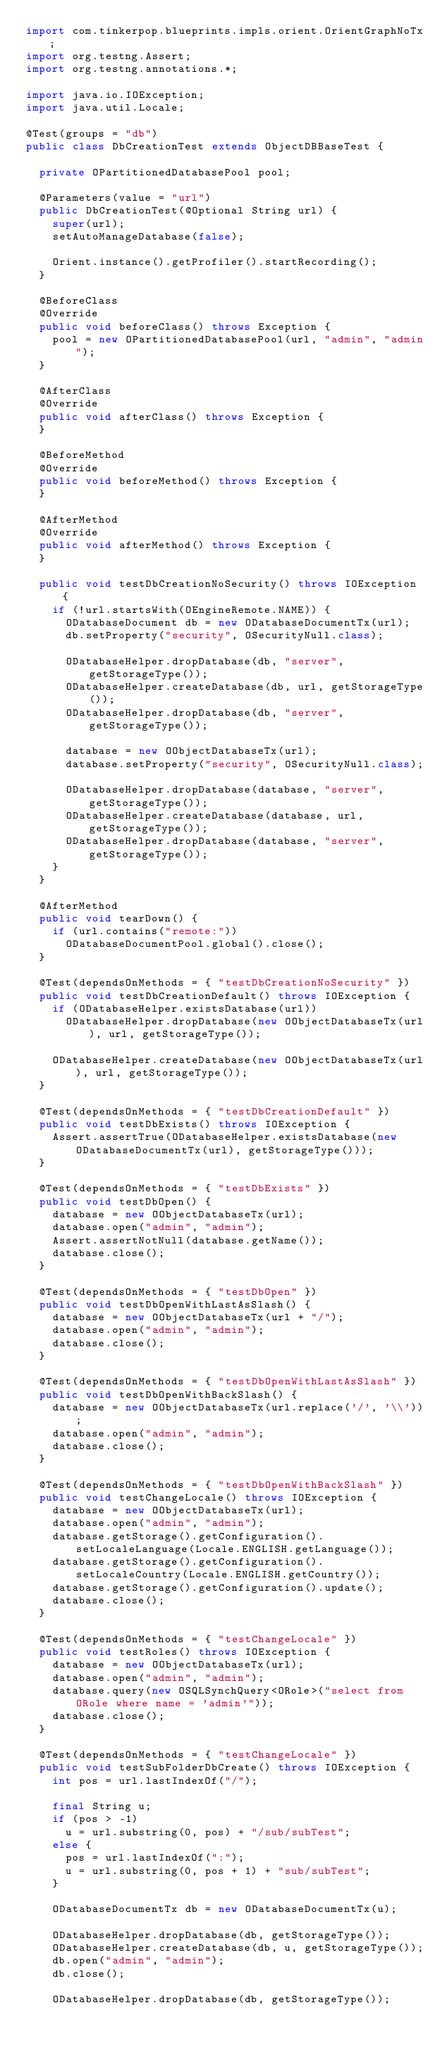<code> <loc_0><loc_0><loc_500><loc_500><_Java_>import com.tinkerpop.blueprints.impls.orient.OrientGraphNoTx;
import org.testng.Assert;
import org.testng.annotations.*;

import java.io.IOException;
import java.util.Locale;

@Test(groups = "db")
public class DbCreationTest extends ObjectDBBaseTest {

  private OPartitionedDatabasePool pool;

  @Parameters(value = "url")
  public DbCreationTest(@Optional String url) {
    super(url);
    setAutoManageDatabase(false);

    Orient.instance().getProfiler().startRecording();
  }

  @BeforeClass
  @Override
  public void beforeClass() throws Exception {
    pool = new OPartitionedDatabasePool(url, "admin", "admin");
  }

  @AfterClass
  @Override
  public void afterClass() throws Exception {
  }

  @BeforeMethod
  @Override
  public void beforeMethod() throws Exception {
  }

  @AfterMethod
  @Override
  public void afterMethod() throws Exception {
  }

  public void testDbCreationNoSecurity() throws IOException {
    if (!url.startsWith(OEngineRemote.NAME)) {
      ODatabaseDocument db = new ODatabaseDocumentTx(url);
      db.setProperty("security", OSecurityNull.class);

      ODatabaseHelper.dropDatabase(db, "server", getStorageType());
      ODatabaseHelper.createDatabase(db, url, getStorageType());
      ODatabaseHelper.dropDatabase(db, "server", getStorageType());

      database = new OObjectDatabaseTx(url);
      database.setProperty("security", OSecurityNull.class);

      ODatabaseHelper.dropDatabase(database, "server", getStorageType());
      ODatabaseHelper.createDatabase(database, url, getStorageType());
      ODatabaseHelper.dropDatabase(database, "server", getStorageType());
    }
  }

  @AfterMethod
  public void tearDown() {
    if (url.contains("remote:"))
      ODatabaseDocumentPool.global().close();
  }

  @Test(dependsOnMethods = { "testDbCreationNoSecurity" })
  public void testDbCreationDefault() throws IOException {
    if (ODatabaseHelper.existsDatabase(url))
      ODatabaseHelper.dropDatabase(new OObjectDatabaseTx(url), url, getStorageType());

    ODatabaseHelper.createDatabase(new OObjectDatabaseTx(url), url, getStorageType());
  }

  @Test(dependsOnMethods = { "testDbCreationDefault" })
  public void testDbExists() throws IOException {
    Assert.assertTrue(ODatabaseHelper.existsDatabase(new ODatabaseDocumentTx(url), getStorageType()));
  }

  @Test(dependsOnMethods = { "testDbExists" })
  public void testDbOpen() {
    database = new OObjectDatabaseTx(url);
    database.open("admin", "admin");
    Assert.assertNotNull(database.getName());
    database.close();
  }

  @Test(dependsOnMethods = { "testDbOpen" })
  public void testDbOpenWithLastAsSlash() {
    database = new OObjectDatabaseTx(url + "/");
    database.open("admin", "admin");
    database.close();
  }

  @Test(dependsOnMethods = { "testDbOpenWithLastAsSlash" })
  public void testDbOpenWithBackSlash() {
    database = new OObjectDatabaseTx(url.replace('/', '\\'));
    database.open("admin", "admin");
    database.close();
  }

  @Test(dependsOnMethods = { "testDbOpenWithBackSlash" })
  public void testChangeLocale() throws IOException {
    database = new OObjectDatabaseTx(url);
    database.open("admin", "admin");
    database.getStorage().getConfiguration().setLocaleLanguage(Locale.ENGLISH.getLanguage());
    database.getStorage().getConfiguration().setLocaleCountry(Locale.ENGLISH.getCountry());
    database.getStorage().getConfiguration().update();
    database.close();
  }

  @Test(dependsOnMethods = { "testChangeLocale" })
  public void testRoles() throws IOException {
    database = new OObjectDatabaseTx(url);
    database.open("admin", "admin");
    database.query(new OSQLSynchQuery<ORole>("select from ORole where name = 'admin'"));
    database.close();
  }

  @Test(dependsOnMethods = { "testChangeLocale" })
  public void testSubFolderDbCreate() throws IOException {
    int pos = url.lastIndexOf("/");

    final String u;
    if (pos > -1)
      u = url.substring(0, pos) + "/sub/subTest";
    else {
      pos = url.lastIndexOf(":");
      u = url.substring(0, pos + 1) + "sub/subTest";
    }

    ODatabaseDocumentTx db = new ODatabaseDocumentTx(u);

    ODatabaseHelper.dropDatabase(db, getStorageType());
    ODatabaseHelper.createDatabase(db, u, getStorageType());
    db.open("admin", "admin");
    db.close();

    ODatabaseHelper.dropDatabase(db, getStorageType());</code> 